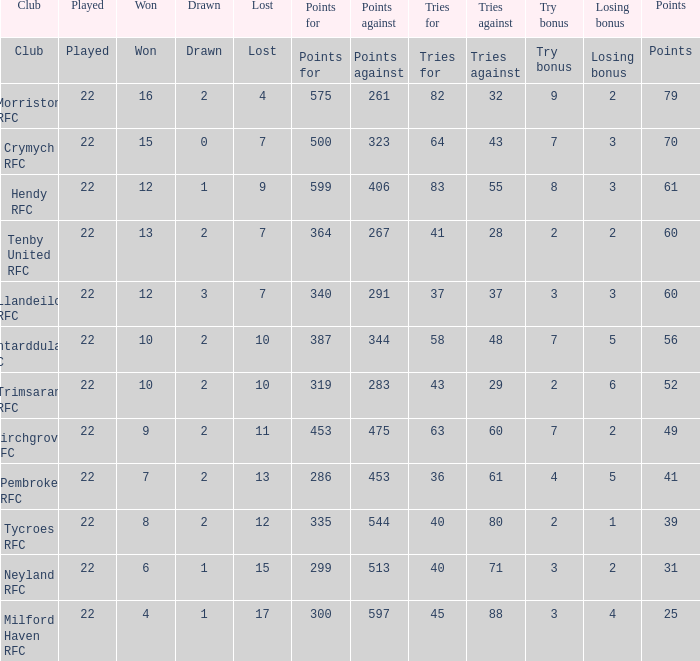Parse the table in full. {'header': ['Club', 'Played', 'Won', 'Drawn', 'Lost', 'Points for', 'Points against', 'Tries for', 'Tries against', 'Try bonus', 'Losing bonus', 'Points'], 'rows': [['Club', 'Played', 'Won', 'Drawn', 'Lost', 'Points for', 'Points against', 'Tries for', 'Tries against', 'Try bonus', 'Losing bonus', 'Points'], ['Morriston RFC', '22', '16', '2', '4', '575', '261', '82', '32', '9', '2', '79'], ['Crymych RFC', '22', '15', '0', '7', '500', '323', '64', '43', '7', '3', '70'], ['Hendy RFC', '22', '12', '1', '9', '599', '406', '83', '55', '8', '3', '61'], ['Tenby United RFC', '22', '13', '2', '7', '364', '267', '41', '28', '2', '2', '60'], ['Llandeilo RFC', '22', '12', '3', '7', '340', '291', '37', '37', '3', '3', '60'], ['Pontarddulais RFC', '22', '10', '2', '10', '387', '344', '58', '48', '7', '5', '56'], ['Trimsaran RFC', '22', '10', '2', '10', '319', '283', '43', '29', '2', '6', '52'], ['Birchgrove RFC', '22', '9', '2', '11', '453', '475', '63', '60', '7', '2', '49'], ['Pembroke RFC', '22', '7', '2', '13', '286', '453', '36', '61', '4', '5', '41'], ['Tycroes RFC', '22', '8', '2', '12', '335', '544', '40', '80', '2', '1', '39'], ['Neyland RFC', '22', '6', '1', '15', '299', '513', '40', '71', '3', '2', '31'], ['Milford Haven RFC', '22', '4', '1', '17', '300', '597', '45', '88', '3', '4', '25']]} What's the points with tries for being 64 70.0. 